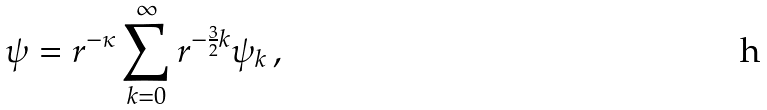<formula> <loc_0><loc_0><loc_500><loc_500>\psi = r ^ { - \kappa } \sum _ { k = 0 } ^ { \infty } r ^ { - \frac { 3 } { 2 } k } \psi _ { k } \, ,</formula> 